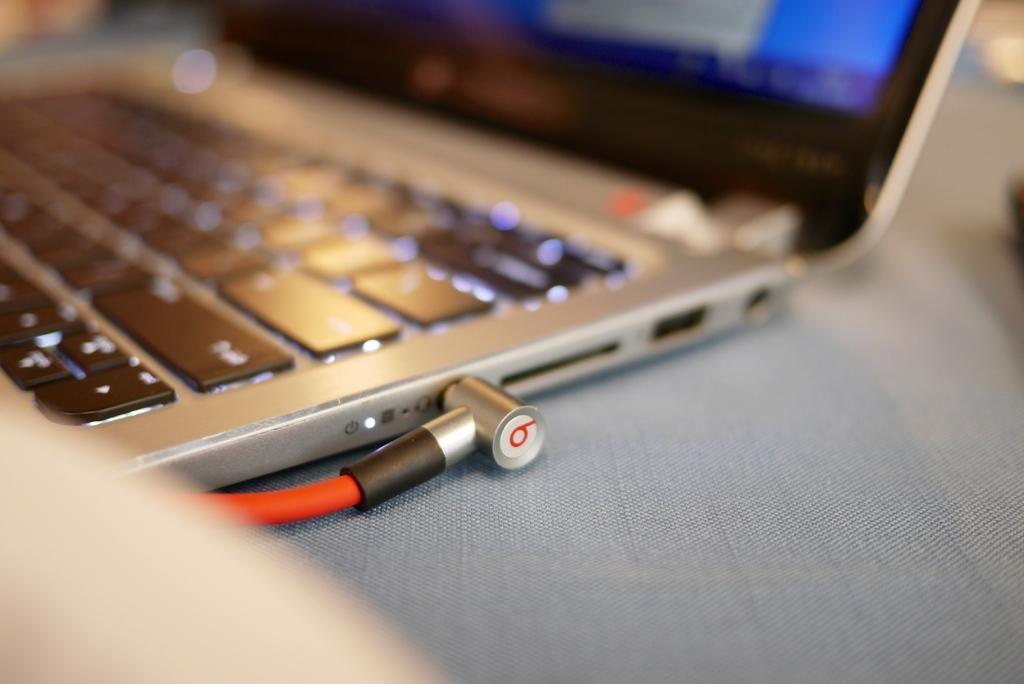<image>
Provide a brief description of the given image. a close up of a computer with a cable with the letter B on it 